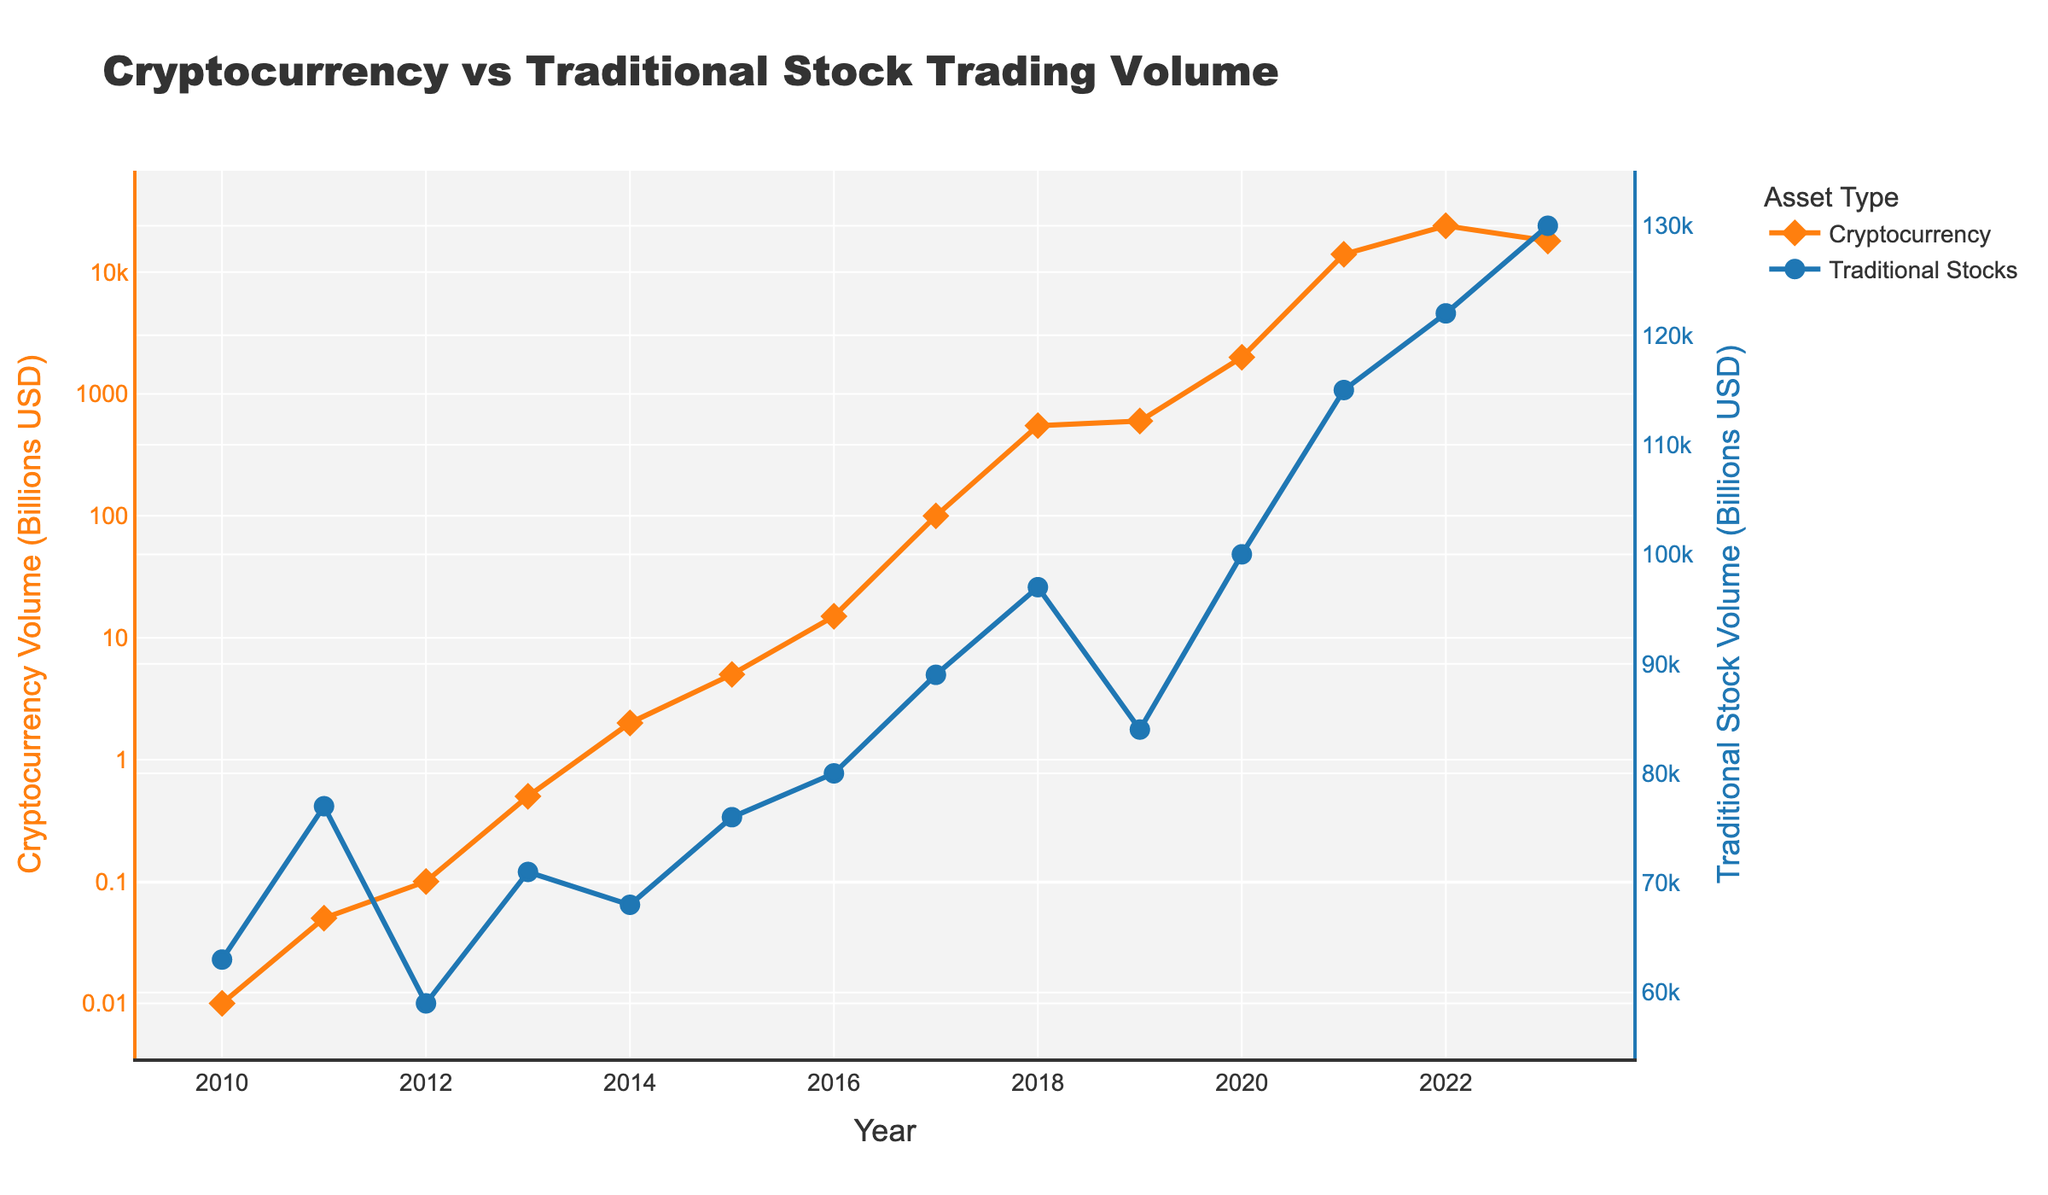What year did cryptocurrency trading volume first exceed 100 billion USD? By observing the plot's markers and lines, the cryptocurrency trading volume first exceeds 100 billion USD in 2017.
Answer: 2017 In which year did the traditional stock trading volume reach its highest value shown in the chart? The plot shows the traditional stock trading volume line peaking at 130,000 billion USD in 2023.
Answer: 2023 What is the approximate difference in trading volume between cryptocurrencies and traditional stocks in 2021? In 2021, cryptocurrency trading volume was 14,000 billion USD, and traditional stock trading volume was 115,000 billion USD. The difference is 115,000 - 14,000 = 101,000 billion USD.
Answer: 101,000 billion USD Identify the span of years during which cryptocurrency trading volume grew from 1 billion to 1,000 billion USD. According to the plot, cryptocurrency trading volume is around 1 billion USD in 2014 and exceeds 1,000 billion USD in 2017.
Answer: 2014-2017 How does the peak trading volume of cryptocurrencies compare to the peak trading volume of traditional stocks? The peak volume for cryptocurrencies is 24,000 billion USD in 2022, and the peak volume for traditional stocks is 130,000 billion USD in 2023. Traditional stocks have a higher peak volume.
Answer: Traditional stocks have higher peak volume What was the cryptocurrency trading volume in 2013 compared to the traditional stock trading volume in the same year? In 2013, the cryptocurrency trading volume was 0.5 billion USD, while the traditional stock trading volume was 71,000 billion USD. Traditional stocks had much higher trading volume.
Answer: Traditional stocks had much higher trading volume Which asset type showed the greatest relative growth from 2010 to 2022? From 2010 to 2022, cryptocurrency trading volume grew from 0.01 billion USD to 24,000 billion USD, while traditional stocks grew from 63,000 billion USD to 122,000 billion USD. Cryptocurrency trading volume shows greater relative growth.
Answer: Cryptocurrency What is the visual difference between the markers used to indicate cryptocurrency and traditional stock trading volumes? The plot uses diamond-shaped markers for cryptocurrency trading volumes (orange) and circle-shaped markers for traditional stock trading volumes (blue).
Answer: Diamon-shaped for cryptocurrency, circle-shaped for traditional stocks By how much did the cryptocurrency trading volume increase from 2018 to 2021? The trading volume for cryptocurrencies in 2018 was 550 billion USD and in 2021 it was 14,000 billion USD. The increase is 14,000 - 550 = 13,450 billion USD.
Answer: 13,450 billion USD 